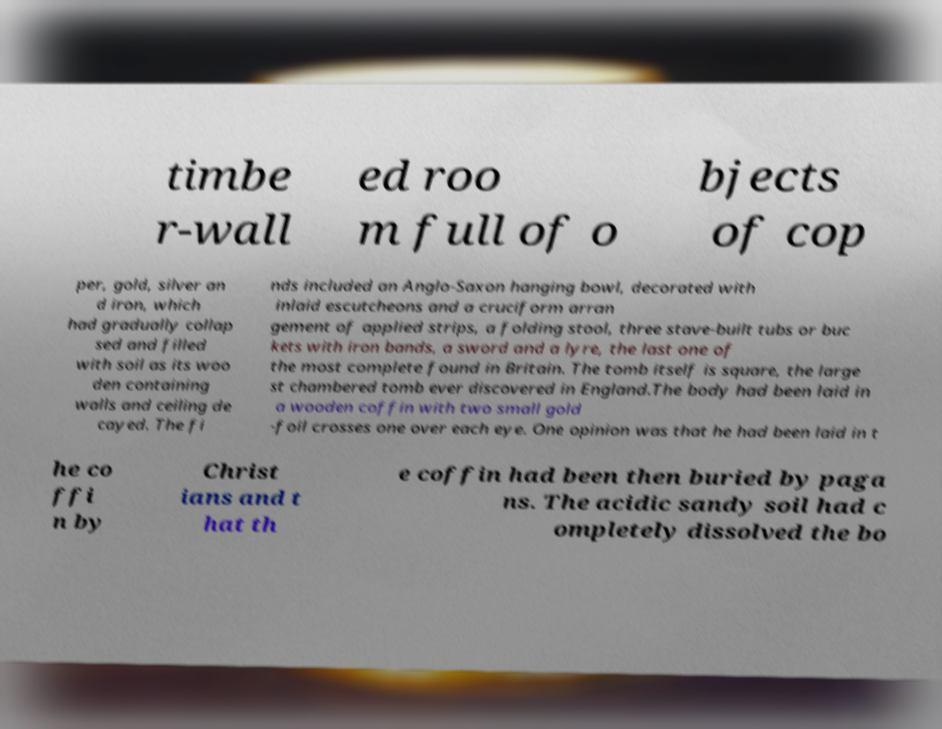Could you assist in decoding the text presented in this image and type it out clearly? timbe r-wall ed roo m full of o bjects of cop per, gold, silver an d iron, which had gradually collap sed and filled with soil as its woo den containing walls and ceiling de cayed. The fi nds included an Anglo-Saxon hanging bowl, decorated with inlaid escutcheons and a cruciform arran gement of applied strips, a folding stool, three stave-built tubs or buc kets with iron bands, a sword and a lyre, the last one of the most complete found in Britain. The tomb itself is square, the large st chambered tomb ever discovered in England.The body had been laid in a wooden coffin with two small gold -foil crosses one over each eye. One opinion was that he had been laid in t he co ffi n by Christ ians and t hat th e coffin had been then buried by paga ns. The acidic sandy soil had c ompletely dissolved the bo 